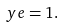<formula> <loc_0><loc_0><loc_500><loc_500>y e = 1 .</formula> 